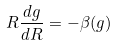<formula> <loc_0><loc_0><loc_500><loc_500>R \frac { d g } { d R } = - \beta ( g )</formula> 